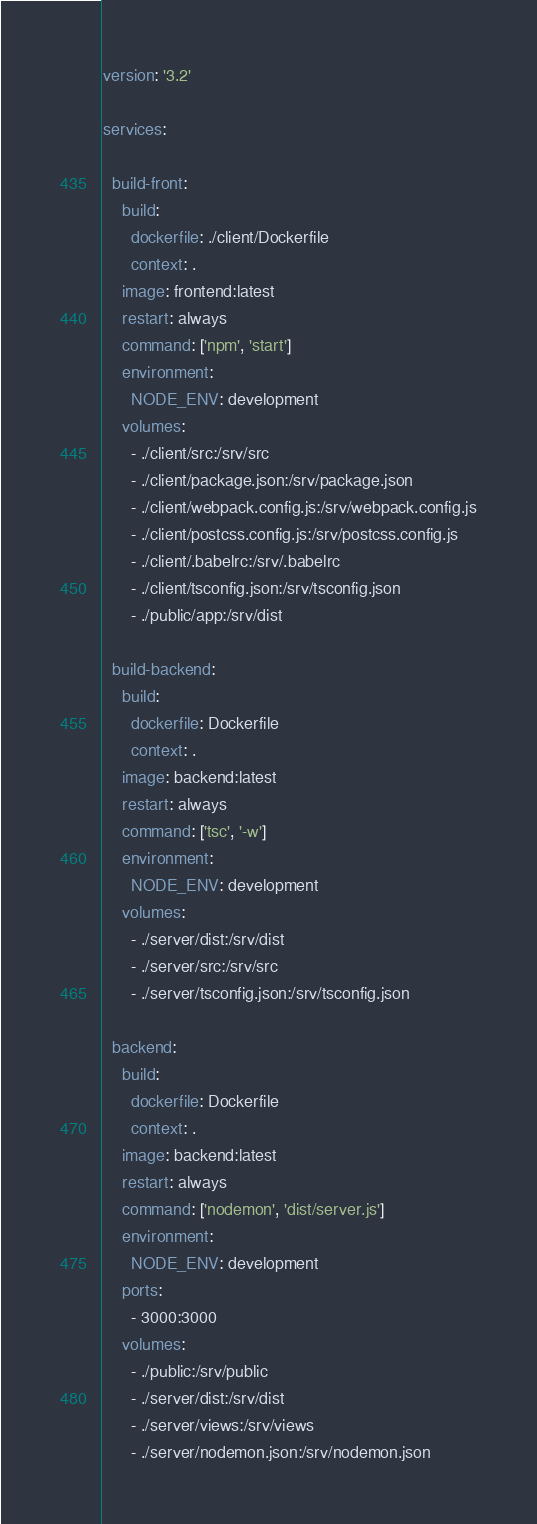Convert code to text. <code><loc_0><loc_0><loc_500><loc_500><_YAML_>version: '3.2'

services:

  build-front:
    build:
      dockerfile: ./client/Dockerfile
      context: .
    image: frontend:latest
    restart: always
    command: ['npm', 'start']
    environment:
      NODE_ENV: development
    volumes:
      - ./client/src:/srv/src
      - ./client/package.json:/srv/package.json
      - ./client/webpack.config.js:/srv/webpack.config.js
      - ./client/postcss.config.js:/srv/postcss.config.js
      - ./client/.babelrc:/srv/.babelrc
      - ./client/tsconfig.json:/srv/tsconfig.json
      - ./public/app:/srv/dist

  build-backend:
    build:
      dockerfile: Dockerfile
      context: .
    image: backend:latest
    restart: always
    command: ['tsc', '-w']
    environment:
      NODE_ENV: development
    volumes:
      - ./server/dist:/srv/dist
      - ./server/src:/srv/src
      - ./server/tsconfig.json:/srv/tsconfig.json

  backend:
    build:
      dockerfile: Dockerfile
      context: .
    image: backend:latest
    restart: always
    command: ['nodemon', 'dist/server.js']
    environment:
      NODE_ENV: development
    ports:
      - 3000:3000
    volumes:
      - ./public:/srv/public
      - ./server/dist:/srv/dist
      - ./server/views:/srv/views
      - ./server/nodemon.json:/srv/nodemon.json
</code> 